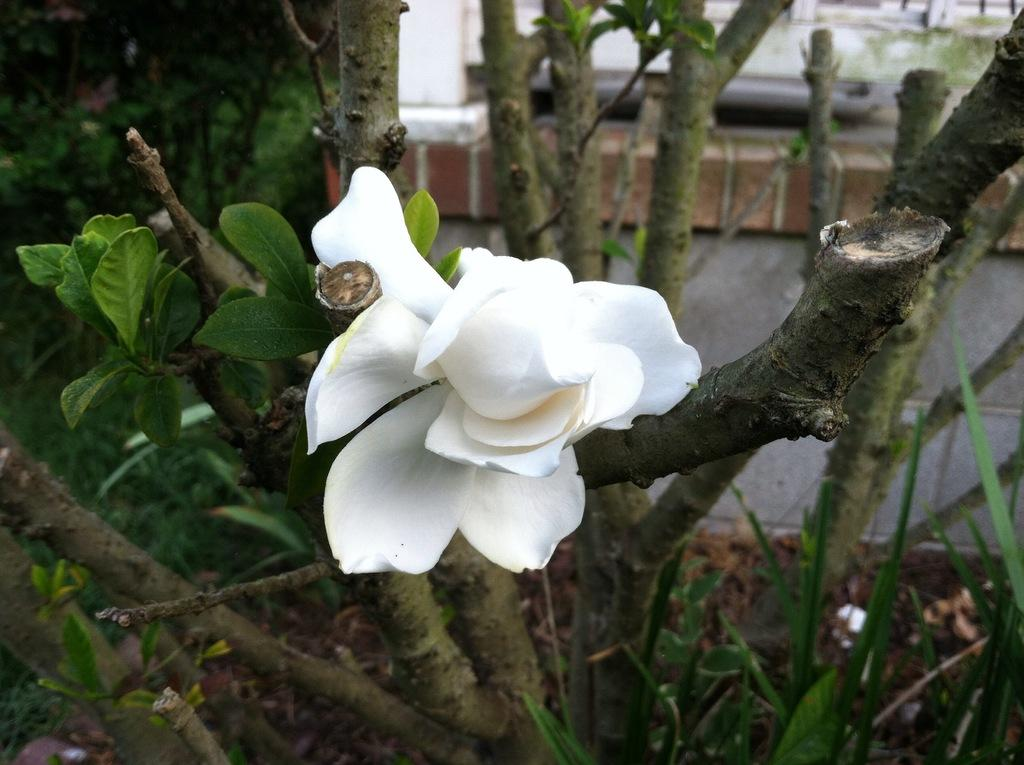What type of living organisms can be seen in the image? Plants can be seen in the image. What part of the plants is visible in the image? Tree stems are present in the image. What color is the flower in the image? There is a white-colored flower in the image. What type of jam is being discussed in the image? There is no discussion or jam present in the image; it features plants and a white-colored flower. 